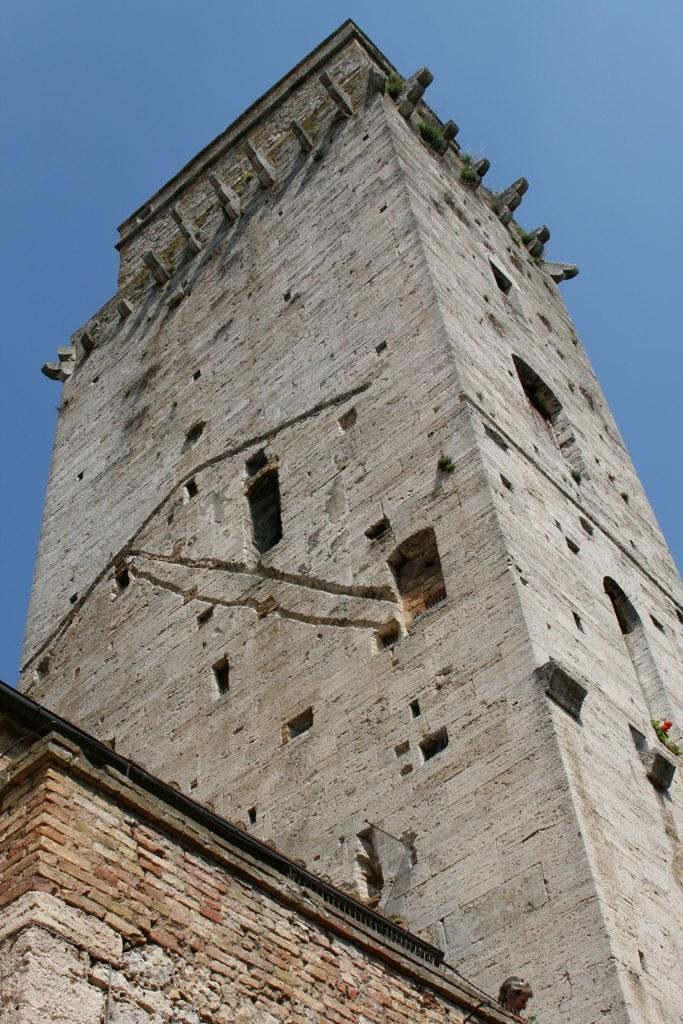In one or two sentences, can you explain what this image depicts? In this image we can see building and windows on it and in the background we can see sky. 